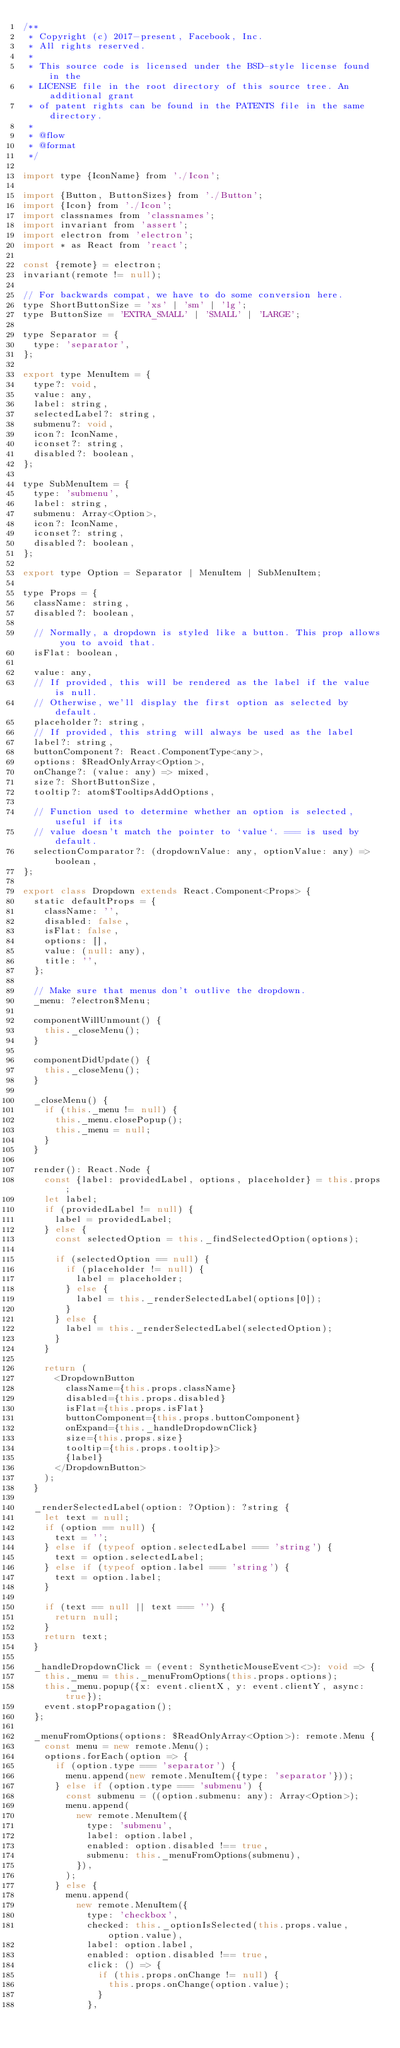Convert code to text. <code><loc_0><loc_0><loc_500><loc_500><_JavaScript_>/**
 * Copyright (c) 2017-present, Facebook, Inc.
 * All rights reserved.
 *
 * This source code is licensed under the BSD-style license found in the
 * LICENSE file in the root directory of this source tree. An additional grant
 * of patent rights can be found in the PATENTS file in the same directory.
 *
 * @flow
 * @format
 */

import type {IconName} from './Icon';

import {Button, ButtonSizes} from './Button';
import {Icon} from './Icon';
import classnames from 'classnames';
import invariant from 'assert';
import electron from 'electron';
import * as React from 'react';

const {remote} = electron;
invariant(remote != null);

// For backwards compat, we have to do some conversion here.
type ShortButtonSize = 'xs' | 'sm' | 'lg';
type ButtonSize = 'EXTRA_SMALL' | 'SMALL' | 'LARGE';

type Separator = {
  type: 'separator',
};

export type MenuItem = {
  type?: void,
  value: any,
  label: string,
  selectedLabel?: string,
  submenu?: void,
  icon?: IconName,
  iconset?: string,
  disabled?: boolean,
};

type SubMenuItem = {
  type: 'submenu',
  label: string,
  submenu: Array<Option>,
  icon?: IconName,
  iconset?: string,
  disabled?: boolean,
};

export type Option = Separator | MenuItem | SubMenuItem;

type Props = {
  className: string,
  disabled?: boolean,

  // Normally, a dropdown is styled like a button. This prop allows you to avoid that.
  isFlat: boolean,

  value: any,
  // If provided, this will be rendered as the label if the value is null.
  // Otherwise, we'll display the first option as selected by default.
  placeholder?: string,
  // If provided, this string will always be used as the label
  label?: string,
  buttonComponent?: React.ComponentType<any>,
  options: $ReadOnlyArray<Option>,
  onChange?: (value: any) => mixed,
  size?: ShortButtonSize,
  tooltip?: atom$TooltipsAddOptions,

  // Function used to determine whether an option is selected, useful if its
  // value doesn't match the pointer to `value`. === is used by default.
  selectionComparator?: (dropdownValue: any, optionValue: any) => boolean,
};

export class Dropdown extends React.Component<Props> {
  static defaultProps = {
    className: '',
    disabled: false,
    isFlat: false,
    options: [],
    value: (null: any),
    title: '',
  };

  // Make sure that menus don't outlive the dropdown.
  _menu: ?electron$Menu;

  componentWillUnmount() {
    this._closeMenu();
  }

  componentDidUpdate() {
    this._closeMenu();
  }

  _closeMenu() {
    if (this._menu != null) {
      this._menu.closePopup();
      this._menu = null;
    }
  }

  render(): React.Node {
    const {label: providedLabel, options, placeholder} = this.props;
    let label;
    if (providedLabel != null) {
      label = providedLabel;
    } else {
      const selectedOption = this._findSelectedOption(options);

      if (selectedOption == null) {
        if (placeholder != null) {
          label = placeholder;
        } else {
          label = this._renderSelectedLabel(options[0]);
        }
      } else {
        label = this._renderSelectedLabel(selectedOption);
      }
    }

    return (
      <DropdownButton
        className={this.props.className}
        disabled={this.props.disabled}
        isFlat={this.props.isFlat}
        buttonComponent={this.props.buttonComponent}
        onExpand={this._handleDropdownClick}
        size={this.props.size}
        tooltip={this.props.tooltip}>
        {label}
      </DropdownButton>
    );
  }

  _renderSelectedLabel(option: ?Option): ?string {
    let text = null;
    if (option == null) {
      text = '';
    } else if (typeof option.selectedLabel === 'string') {
      text = option.selectedLabel;
    } else if (typeof option.label === 'string') {
      text = option.label;
    }

    if (text == null || text === '') {
      return null;
    }
    return text;
  }

  _handleDropdownClick = (event: SyntheticMouseEvent<>): void => {
    this._menu = this._menuFromOptions(this.props.options);
    this._menu.popup({x: event.clientX, y: event.clientY, async: true});
    event.stopPropagation();
  };

  _menuFromOptions(options: $ReadOnlyArray<Option>): remote.Menu {
    const menu = new remote.Menu();
    options.forEach(option => {
      if (option.type === 'separator') {
        menu.append(new remote.MenuItem({type: 'separator'}));
      } else if (option.type === 'submenu') {
        const submenu = ((option.submenu: any): Array<Option>);
        menu.append(
          new remote.MenuItem({
            type: 'submenu',
            label: option.label,
            enabled: option.disabled !== true,
            submenu: this._menuFromOptions(submenu),
          }),
        );
      } else {
        menu.append(
          new remote.MenuItem({
            type: 'checkbox',
            checked: this._optionIsSelected(this.props.value, option.value),
            label: option.label,
            enabled: option.disabled !== true,
            click: () => {
              if (this.props.onChange != null) {
                this.props.onChange(option.value);
              }
            },</code> 